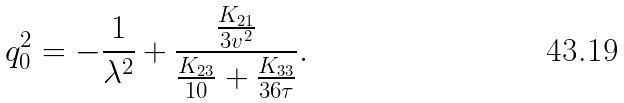<formula> <loc_0><loc_0><loc_500><loc_500>q _ { 0 } ^ { 2 } = - \frac { 1 } { \lambda ^ { 2 } } + \frac { \frac { K _ { 2 1 } } { 3 v ^ { 2 } } } { \frac { K _ { 2 3 } } { 1 0 } + \frac { K _ { 3 3 } } { 3 6 \tau } } .</formula> 